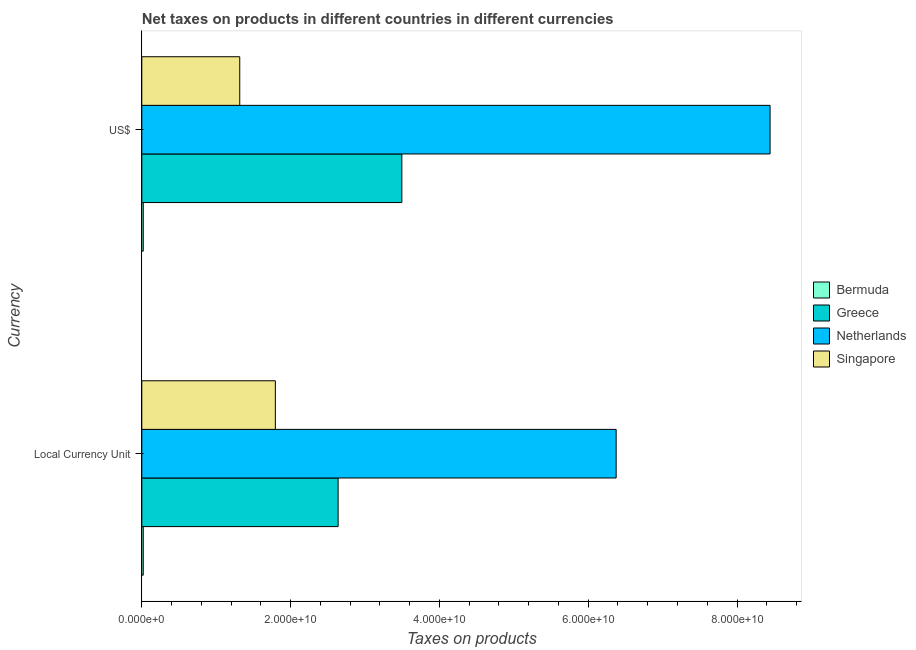How many different coloured bars are there?
Offer a terse response. 4. Are the number of bars on each tick of the Y-axis equal?
Ensure brevity in your answer.  Yes. What is the label of the 2nd group of bars from the top?
Ensure brevity in your answer.  Local Currency Unit. What is the net taxes in us$ in Singapore?
Offer a terse response. 1.32e+1. Across all countries, what is the maximum net taxes in constant 2005 us$?
Offer a terse response. 6.38e+1. Across all countries, what is the minimum net taxes in us$?
Offer a very short reply. 1.95e+08. In which country was the net taxes in constant 2005 us$ minimum?
Provide a succinct answer. Bermuda. What is the total net taxes in us$ in the graph?
Make the answer very short. 1.33e+11. What is the difference between the net taxes in constant 2005 us$ in Singapore and that in Bermuda?
Your answer should be compact. 1.78e+1. What is the difference between the net taxes in constant 2005 us$ in Greece and the net taxes in us$ in Bermuda?
Your response must be concise. 2.62e+1. What is the average net taxes in us$ per country?
Provide a succinct answer. 3.32e+1. What is the difference between the net taxes in us$ and net taxes in constant 2005 us$ in Greece?
Your response must be concise. 8.56e+09. What is the ratio of the net taxes in constant 2005 us$ in Singapore to that in Greece?
Your response must be concise. 0.68. Is the net taxes in constant 2005 us$ in Greece less than that in Singapore?
Provide a succinct answer. No. In how many countries, is the net taxes in us$ greater than the average net taxes in us$ taken over all countries?
Your response must be concise. 2. What does the 3rd bar from the top in Local Currency Unit represents?
Offer a terse response. Greece. What does the 4th bar from the bottom in Local Currency Unit represents?
Ensure brevity in your answer.  Singapore. What is the difference between two consecutive major ticks on the X-axis?
Offer a very short reply. 2.00e+1. Does the graph contain any zero values?
Give a very brief answer. No. Where does the legend appear in the graph?
Give a very brief answer. Center right. How many legend labels are there?
Keep it short and to the point. 4. What is the title of the graph?
Offer a terse response. Net taxes on products in different countries in different currencies. What is the label or title of the X-axis?
Offer a very short reply. Taxes on products. What is the label or title of the Y-axis?
Offer a very short reply. Currency. What is the Taxes on products in Bermuda in Local Currency Unit?
Your response must be concise. 1.95e+08. What is the Taxes on products of Greece in Local Currency Unit?
Offer a very short reply. 2.64e+1. What is the Taxes on products of Netherlands in Local Currency Unit?
Your answer should be very brief. 6.38e+1. What is the Taxes on products in Singapore in Local Currency Unit?
Offer a terse response. 1.80e+1. What is the Taxes on products in Bermuda in US$?
Ensure brevity in your answer.  1.95e+08. What is the Taxes on products of Greece in US$?
Offer a terse response. 3.50e+1. What is the Taxes on products of Netherlands in US$?
Offer a terse response. 8.44e+1. What is the Taxes on products in Singapore in US$?
Your answer should be very brief. 1.32e+1. Across all Currency, what is the maximum Taxes on products of Bermuda?
Your answer should be compact. 1.95e+08. Across all Currency, what is the maximum Taxes on products of Greece?
Your answer should be compact. 3.50e+1. Across all Currency, what is the maximum Taxes on products in Netherlands?
Provide a succinct answer. 8.44e+1. Across all Currency, what is the maximum Taxes on products in Singapore?
Make the answer very short. 1.80e+1. Across all Currency, what is the minimum Taxes on products in Bermuda?
Offer a terse response. 1.95e+08. Across all Currency, what is the minimum Taxes on products of Greece?
Provide a succinct answer. 2.64e+1. Across all Currency, what is the minimum Taxes on products of Netherlands?
Provide a succinct answer. 6.38e+1. Across all Currency, what is the minimum Taxes on products in Singapore?
Ensure brevity in your answer.  1.32e+1. What is the total Taxes on products in Bermuda in the graph?
Ensure brevity in your answer.  3.90e+08. What is the total Taxes on products in Greece in the graph?
Keep it short and to the point. 6.13e+1. What is the total Taxes on products of Netherlands in the graph?
Your response must be concise. 1.48e+11. What is the total Taxes on products of Singapore in the graph?
Your answer should be compact. 3.11e+1. What is the difference between the Taxes on products in Bermuda in Local Currency Unit and that in US$?
Provide a short and direct response. 0. What is the difference between the Taxes on products in Greece in Local Currency Unit and that in US$?
Offer a very short reply. -8.56e+09. What is the difference between the Taxes on products in Netherlands in Local Currency Unit and that in US$?
Ensure brevity in your answer.  -2.07e+1. What is the difference between the Taxes on products of Singapore in Local Currency Unit and that in US$?
Your answer should be compact. 4.79e+09. What is the difference between the Taxes on products in Bermuda in Local Currency Unit and the Taxes on products in Greece in US$?
Provide a succinct answer. -3.48e+1. What is the difference between the Taxes on products of Bermuda in Local Currency Unit and the Taxes on products of Netherlands in US$?
Ensure brevity in your answer.  -8.42e+1. What is the difference between the Taxes on products of Bermuda in Local Currency Unit and the Taxes on products of Singapore in US$?
Provide a succinct answer. -1.30e+1. What is the difference between the Taxes on products of Greece in Local Currency Unit and the Taxes on products of Netherlands in US$?
Give a very brief answer. -5.81e+1. What is the difference between the Taxes on products of Greece in Local Currency Unit and the Taxes on products of Singapore in US$?
Offer a terse response. 1.32e+1. What is the difference between the Taxes on products in Netherlands in Local Currency Unit and the Taxes on products in Singapore in US$?
Give a very brief answer. 5.06e+1. What is the average Taxes on products in Bermuda per Currency?
Ensure brevity in your answer.  1.95e+08. What is the average Taxes on products in Greece per Currency?
Offer a terse response. 3.07e+1. What is the average Taxes on products of Netherlands per Currency?
Give a very brief answer. 7.41e+1. What is the average Taxes on products in Singapore per Currency?
Your answer should be very brief. 1.56e+1. What is the difference between the Taxes on products in Bermuda and Taxes on products in Greece in Local Currency Unit?
Offer a very short reply. -2.62e+1. What is the difference between the Taxes on products in Bermuda and Taxes on products in Netherlands in Local Currency Unit?
Ensure brevity in your answer.  -6.36e+1. What is the difference between the Taxes on products of Bermuda and Taxes on products of Singapore in Local Currency Unit?
Make the answer very short. -1.78e+1. What is the difference between the Taxes on products in Greece and Taxes on products in Netherlands in Local Currency Unit?
Make the answer very short. -3.74e+1. What is the difference between the Taxes on products of Greece and Taxes on products of Singapore in Local Currency Unit?
Offer a terse response. 8.44e+09. What is the difference between the Taxes on products in Netherlands and Taxes on products in Singapore in Local Currency Unit?
Your answer should be compact. 4.58e+1. What is the difference between the Taxes on products in Bermuda and Taxes on products in Greece in US$?
Your response must be concise. -3.48e+1. What is the difference between the Taxes on products in Bermuda and Taxes on products in Netherlands in US$?
Provide a succinct answer. -8.42e+1. What is the difference between the Taxes on products of Bermuda and Taxes on products of Singapore in US$?
Your answer should be compact. -1.30e+1. What is the difference between the Taxes on products in Greece and Taxes on products in Netherlands in US$?
Offer a terse response. -4.95e+1. What is the difference between the Taxes on products of Greece and Taxes on products of Singapore in US$?
Make the answer very short. 2.18e+1. What is the difference between the Taxes on products in Netherlands and Taxes on products in Singapore in US$?
Give a very brief answer. 7.13e+1. What is the ratio of the Taxes on products of Bermuda in Local Currency Unit to that in US$?
Your answer should be compact. 1. What is the ratio of the Taxes on products of Greece in Local Currency Unit to that in US$?
Your response must be concise. 0.76. What is the ratio of the Taxes on products of Netherlands in Local Currency Unit to that in US$?
Offer a terse response. 0.76. What is the ratio of the Taxes on products in Singapore in Local Currency Unit to that in US$?
Your answer should be compact. 1.36. What is the difference between the highest and the second highest Taxes on products of Bermuda?
Ensure brevity in your answer.  0. What is the difference between the highest and the second highest Taxes on products in Greece?
Keep it short and to the point. 8.56e+09. What is the difference between the highest and the second highest Taxes on products of Netherlands?
Your response must be concise. 2.07e+1. What is the difference between the highest and the second highest Taxes on products of Singapore?
Provide a succinct answer. 4.79e+09. What is the difference between the highest and the lowest Taxes on products of Bermuda?
Your response must be concise. 0. What is the difference between the highest and the lowest Taxes on products in Greece?
Keep it short and to the point. 8.56e+09. What is the difference between the highest and the lowest Taxes on products of Netherlands?
Offer a terse response. 2.07e+1. What is the difference between the highest and the lowest Taxes on products of Singapore?
Offer a very short reply. 4.79e+09. 